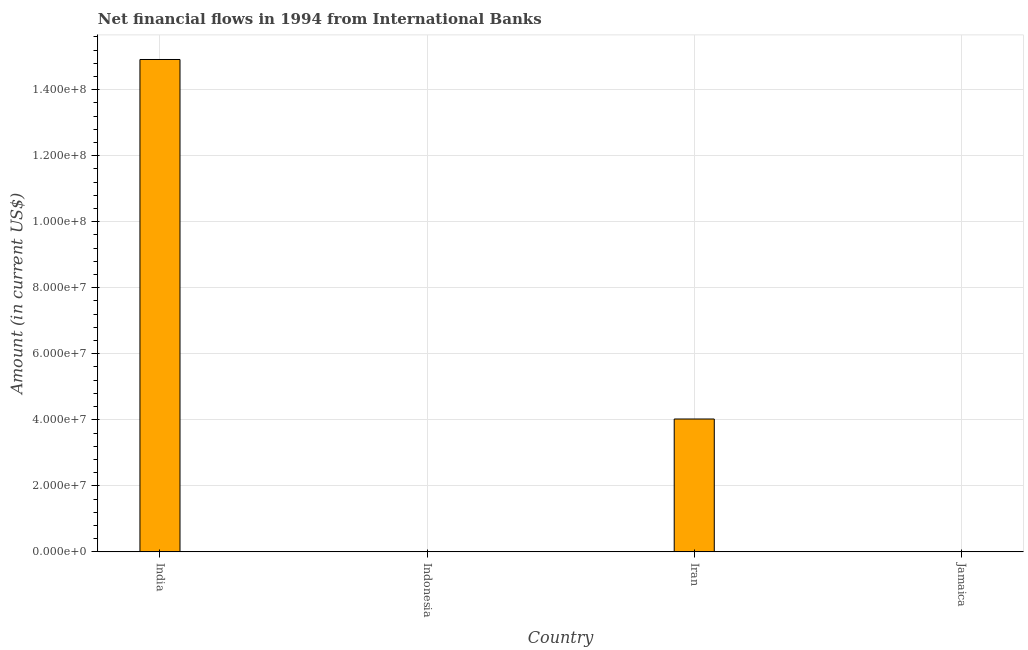Does the graph contain grids?
Your answer should be very brief. Yes. What is the title of the graph?
Ensure brevity in your answer.  Net financial flows in 1994 from International Banks. What is the label or title of the Y-axis?
Your answer should be very brief. Amount (in current US$). What is the net financial flows from ibrd in Jamaica?
Provide a succinct answer. 0. Across all countries, what is the maximum net financial flows from ibrd?
Make the answer very short. 1.49e+08. What is the sum of the net financial flows from ibrd?
Give a very brief answer. 1.89e+08. What is the difference between the net financial flows from ibrd in India and Iran?
Your answer should be compact. 1.09e+08. What is the average net financial flows from ibrd per country?
Your answer should be very brief. 4.73e+07. What is the median net financial flows from ibrd?
Your answer should be compact. 2.01e+07. What is the ratio of the net financial flows from ibrd in India to that in Iran?
Your answer should be compact. 3.71. Is the sum of the net financial flows from ibrd in India and Iran greater than the maximum net financial flows from ibrd across all countries?
Keep it short and to the point. Yes. What is the difference between the highest and the lowest net financial flows from ibrd?
Offer a very short reply. 1.49e+08. How many bars are there?
Your answer should be compact. 2. What is the difference between two consecutive major ticks on the Y-axis?
Your answer should be very brief. 2.00e+07. Are the values on the major ticks of Y-axis written in scientific E-notation?
Ensure brevity in your answer.  Yes. What is the Amount (in current US$) in India?
Your answer should be very brief. 1.49e+08. What is the Amount (in current US$) in Iran?
Your answer should be very brief. 4.02e+07. What is the difference between the Amount (in current US$) in India and Iran?
Ensure brevity in your answer.  1.09e+08. What is the ratio of the Amount (in current US$) in India to that in Iran?
Offer a very short reply. 3.71. 